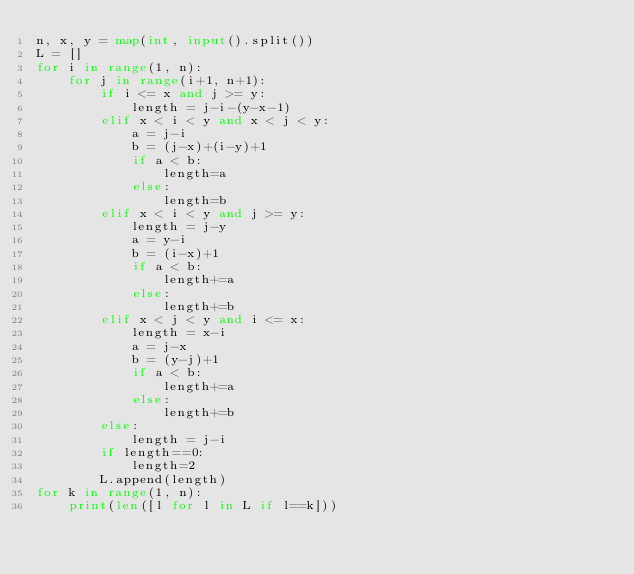<code> <loc_0><loc_0><loc_500><loc_500><_Python_>n, x, y = map(int, input().split())
L = []
for i in range(1, n):
    for j in range(i+1, n+1):
        if i <= x and j >= y:
            length = j-i-(y-x-1)
        elif x < i < y and x < j < y:
            a = j-i
            b = (j-x)+(i-y)+1
            if a < b:
                length=a
            else:
                length=b
        elif x < i < y and j >= y:
            length = j-y
            a = y-i
            b = (i-x)+1
            if a < b:
                length+=a
            else:
                length+=b
        elif x < j < y and i <= x:
            length = x-i
            a = j-x
            b = (y-j)+1
            if a < b:
                length+=a
            else:
                length+=b
        else:
            length = j-i
        if length==0:
            length=2
        L.append(length)
for k in range(1, n):
    print(len([l for l in L if l==k]))</code> 